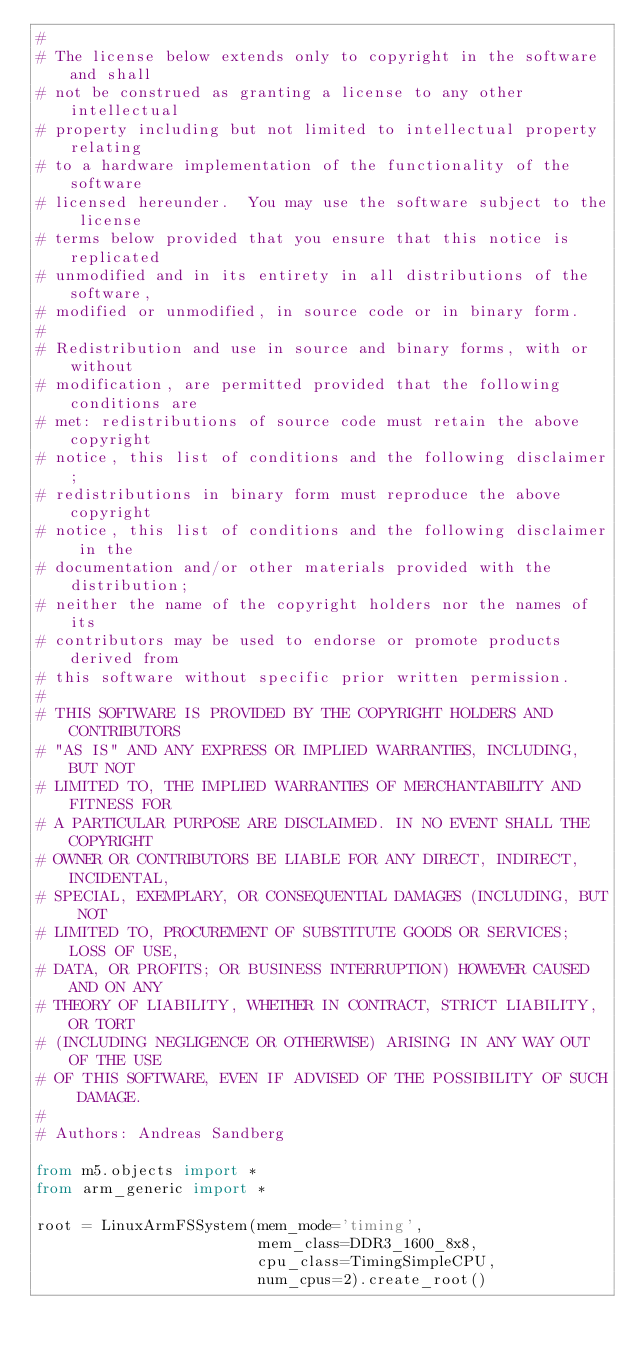Convert code to text. <code><loc_0><loc_0><loc_500><loc_500><_Python_>#
# The license below extends only to copyright in the software and shall
# not be construed as granting a license to any other intellectual
# property including but not limited to intellectual property relating
# to a hardware implementation of the functionality of the software
# licensed hereunder.  You may use the software subject to the license
# terms below provided that you ensure that this notice is replicated
# unmodified and in its entirety in all distributions of the software,
# modified or unmodified, in source code or in binary form.
#
# Redistribution and use in source and binary forms, with or without
# modification, are permitted provided that the following conditions are
# met: redistributions of source code must retain the above copyright
# notice, this list of conditions and the following disclaimer;
# redistributions in binary form must reproduce the above copyright
# notice, this list of conditions and the following disclaimer in the
# documentation and/or other materials provided with the distribution;
# neither the name of the copyright holders nor the names of its
# contributors may be used to endorse or promote products derived from
# this software without specific prior written permission.
#
# THIS SOFTWARE IS PROVIDED BY THE COPYRIGHT HOLDERS AND CONTRIBUTORS
# "AS IS" AND ANY EXPRESS OR IMPLIED WARRANTIES, INCLUDING, BUT NOT
# LIMITED TO, THE IMPLIED WARRANTIES OF MERCHANTABILITY AND FITNESS FOR
# A PARTICULAR PURPOSE ARE DISCLAIMED. IN NO EVENT SHALL THE COPYRIGHT
# OWNER OR CONTRIBUTORS BE LIABLE FOR ANY DIRECT, INDIRECT, INCIDENTAL,
# SPECIAL, EXEMPLARY, OR CONSEQUENTIAL DAMAGES (INCLUDING, BUT NOT
# LIMITED TO, PROCUREMENT OF SUBSTITUTE GOODS OR SERVICES; LOSS OF USE,
# DATA, OR PROFITS; OR BUSINESS INTERRUPTION) HOWEVER CAUSED AND ON ANY
# THEORY OF LIABILITY, WHETHER IN CONTRACT, STRICT LIABILITY, OR TORT
# (INCLUDING NEGLIGENCE OR OTHERWISE) ARISING IN ANY WAY OUT OF THE USE
# OF THIS SOFTWARE, EVEN IF ADVISED OF THE POSSIBILITY OF SUCH DAMAGE.
#
# Authors: Andreas Sandberg

from m5.objects import *
from arm_generic import *

root = LinuxArmFSSystem(mem_mode='timing',
                        mem_class=DDR3_1600_8x8,
                        cpu_class=TimingSimpleCPU,
                        num_cpus=2).create_root()
</code> 